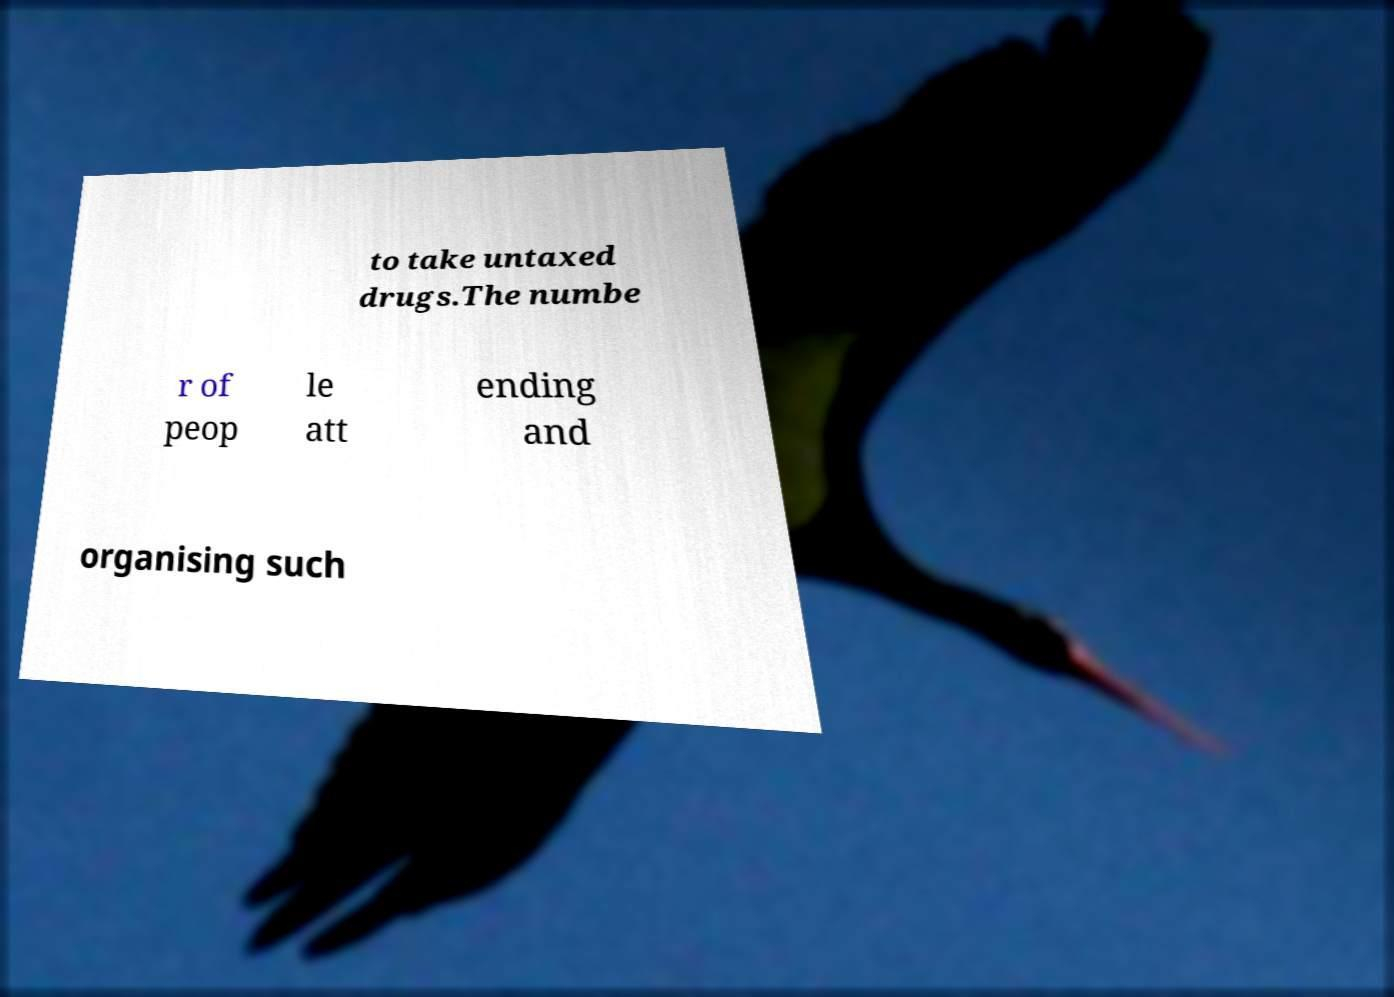Can you read and provide the text displayed in the image?This photo seems to have some interesting text. Can you extract and type it out for me? to take untaxed drugs.The numbe r of peop le att ending and organising such 